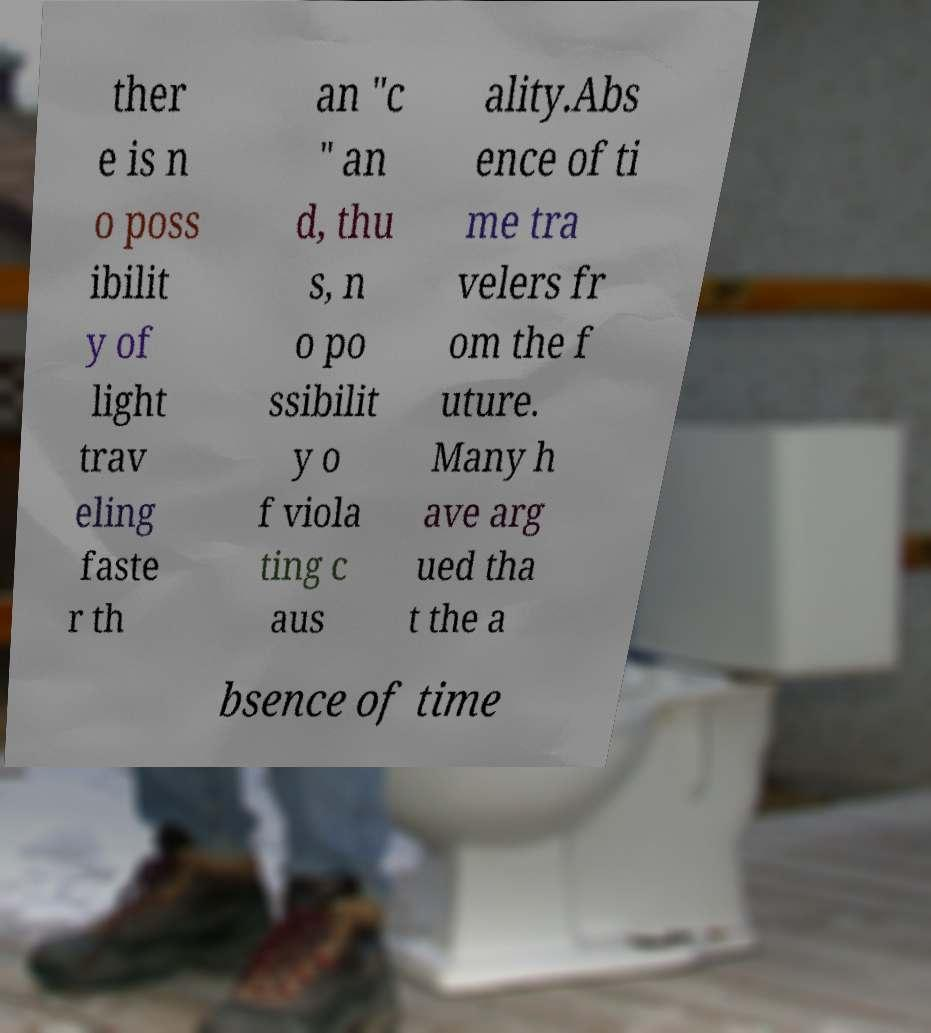Could you assist in decoding the text presented in this image and type it out clearly? ther e is n o poss ibilit y of light trav eling faste r th an "c " an d, thu s, n o po ssibilit y o f viola ting c aus ality.Abs ence of ti me tra velers fr om the f uture. Many h ave arg ued tha t the a bsence of time 